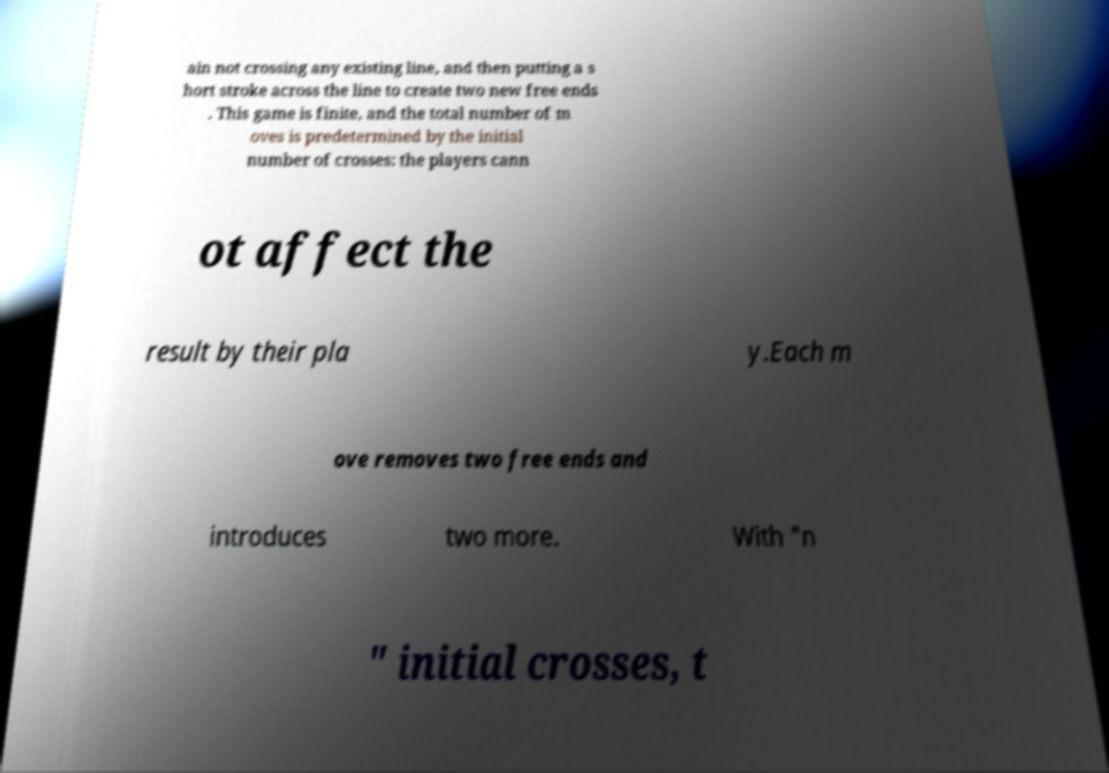There's text embedded in this image that I need extracted. Can you transcribe it verbatim? ain not crossing any existing line, and then putting a s hort stroke across the line to create two new free ends . This game is finite, and the total number of m oves is predetermined by the initial number of crosses: the players cann ot affect the result by their pla y.Each m ove removes two free ends and introduces two more. With "n " initial crosses, t 